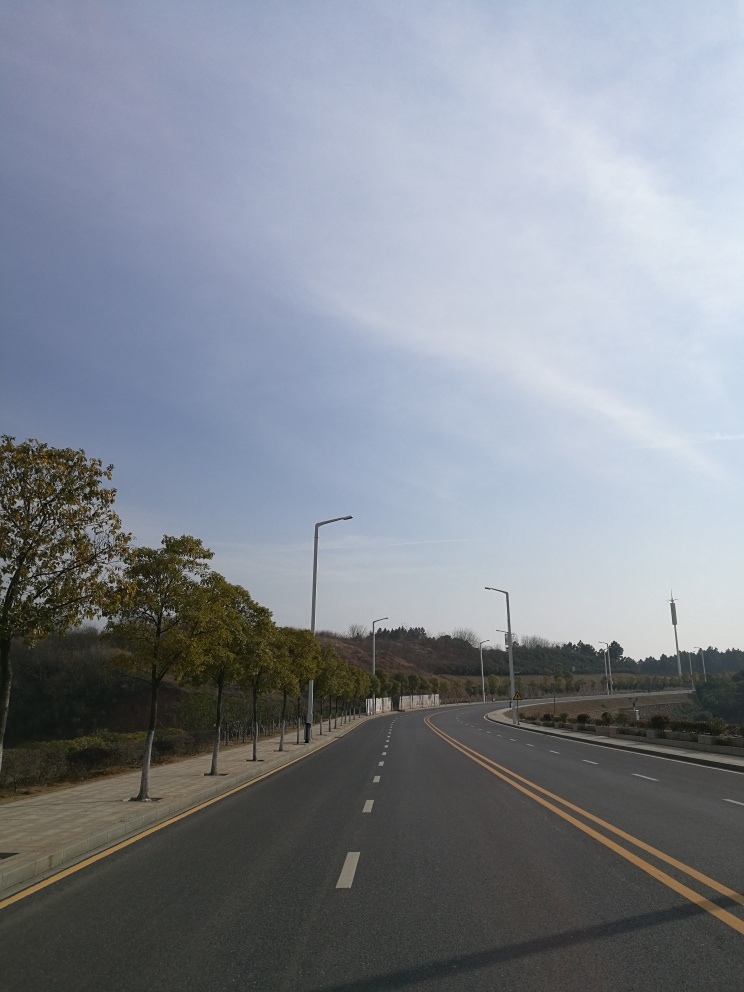Are the colors vibrant? The colors in the image are somewhat muted, with a calming palette of blues and soft grays in the sky, and gentle yellows and greens from the trees along the road. While the image gives off a serene vibe, it does not display the kind of vivid or bright colors typically described as 'vibrant'. 